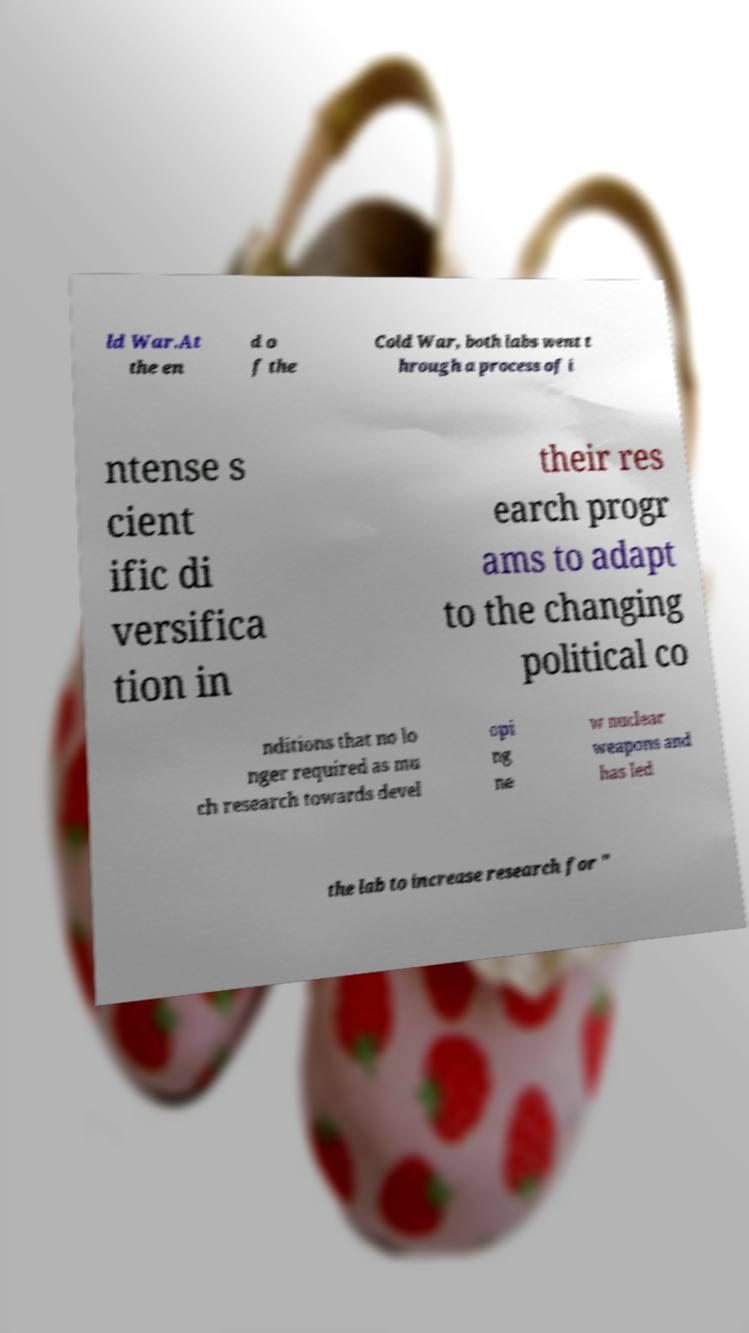For documentation purposes, I need the text within this image transcribed. Could you provide that? ld War.At the en d o f the Cold War, both labs went t hrough a process of i ntense s cient ific di versifica tion in their res earch progr ams to adapt to the changing political co nditions that no lo nger required as mu ch research towards devel opi ng ne w nuclear weapons and has led the lab to increase research for " 